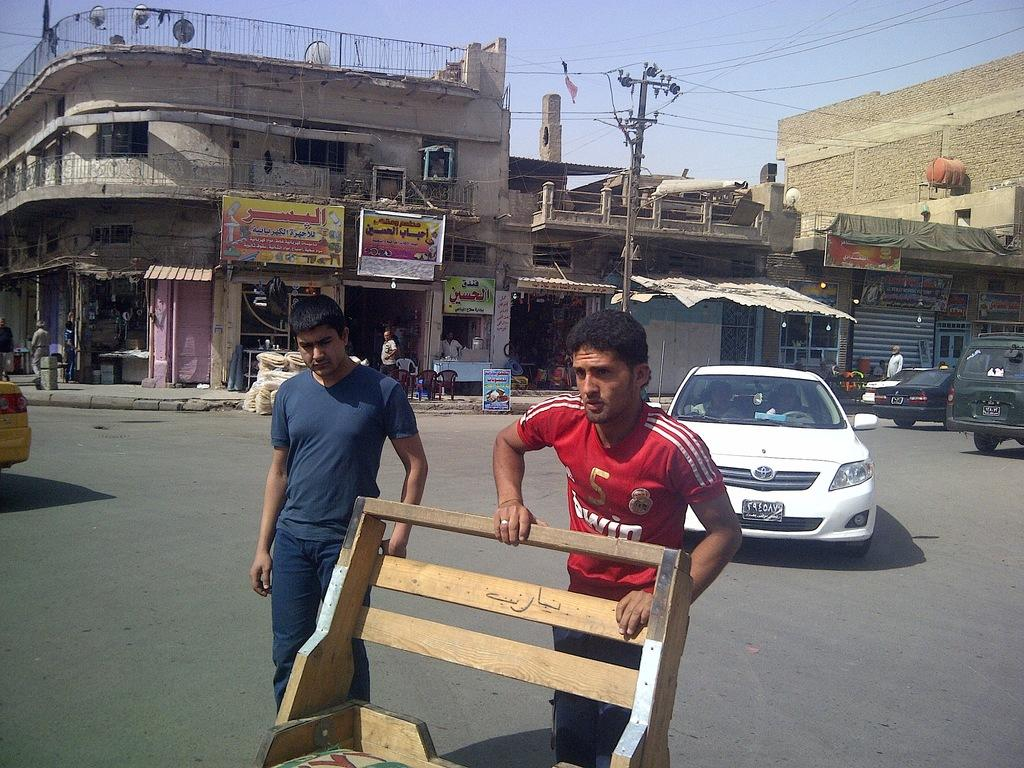How many persons are on the road in the image? There are two persons on the road in the image. What is behind the persons on the road? There are vehicles behind the persons on the road. What can be seen in the background of the image? There are buildings, electric poles, the sky, a hoarding, and people in the background. What type of lunch is the farmer eating in the image? There is no farmer or lunch present in the image. What is the farmer doing with the boot in the image? There is no farmer or boot present in the image. 